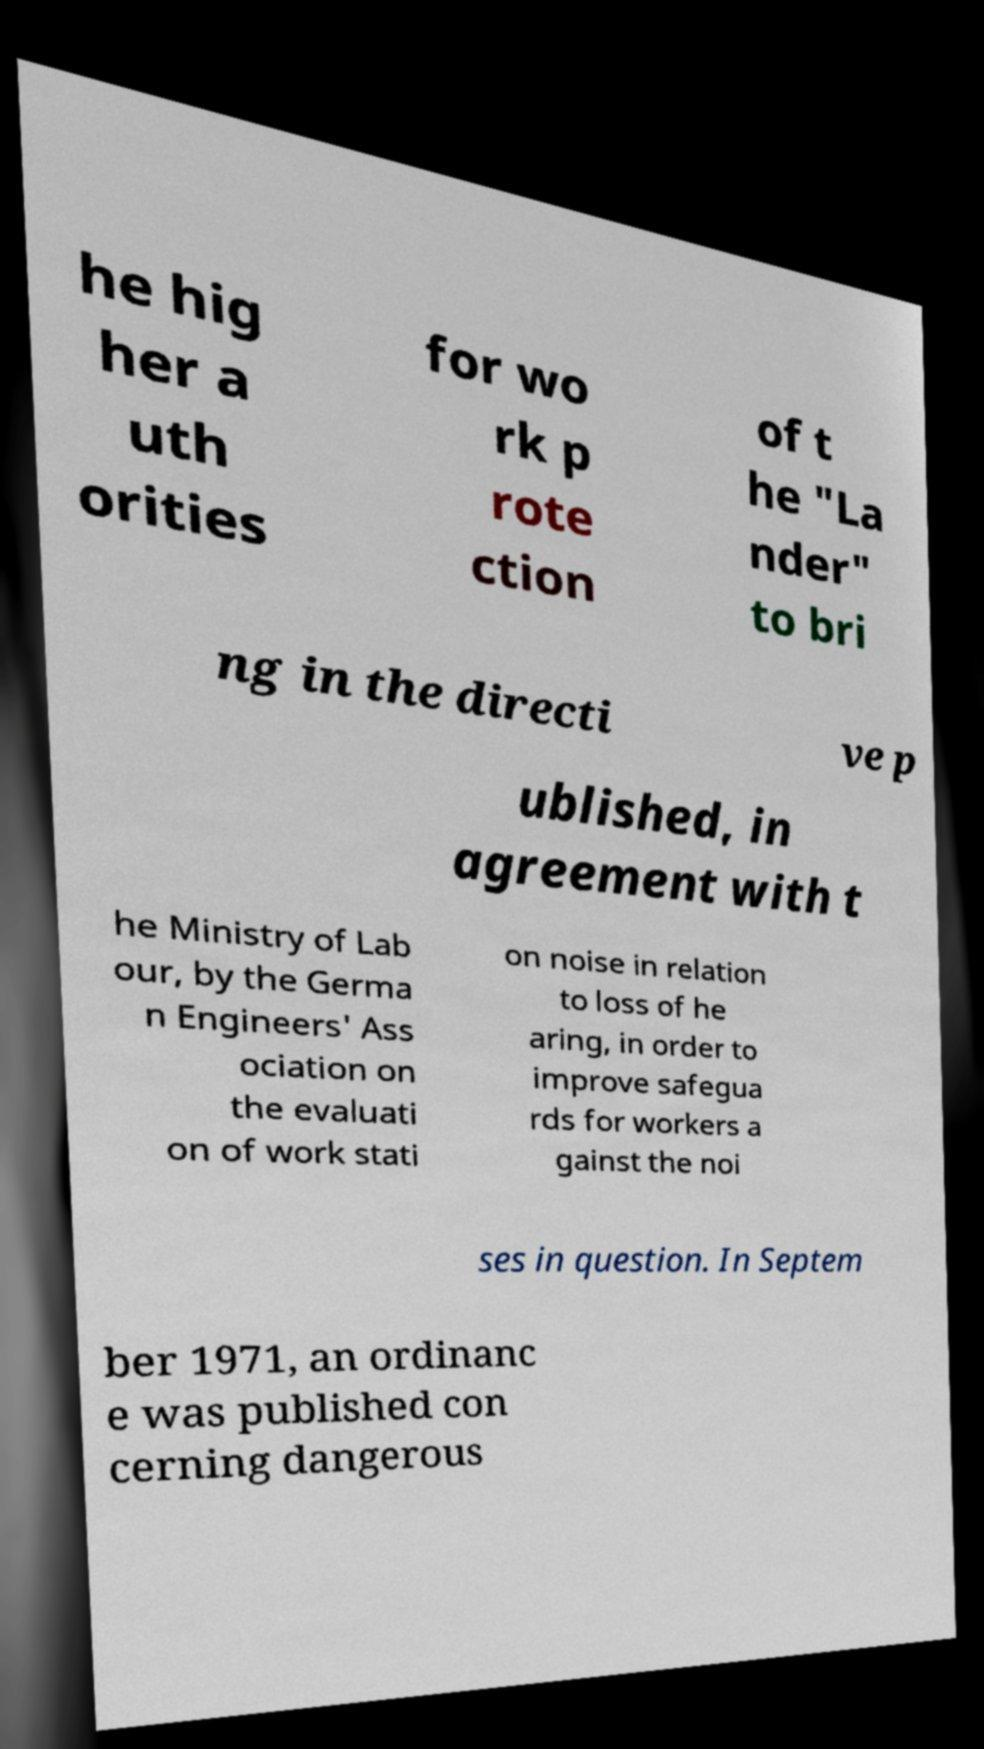Could you assist in decoding the text presented in this image and type it out clearly? he hig her a uth orities for wo rk p rote ction of t he "La nder" to bri ng in the directi ve p ublished, in agreement with t he Ministry of Lab our, by the Germa n Engineers' Ass ociation on the evaluati on of work stati on noise in relation to loss of he aring, in order to improve safegua rds for workers a gainst the noi ses in question. In Septem ber 1971, an ordinanc e was published con cerning dangerous 